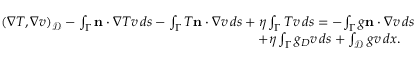<formula> <loc_0><loc_0><loc_500><loc_500>\begin{array} { r } { ( \nabla T , \nabla v ) _ { \mathcal { D } } - \int _ { \Gamma } { n } \cdot { \nabla } T v \, d s - { \int _ { \Gamma } T { n } \cdot { \nabla } v \, d s } + { \eta \int _ { \Gamma } T v \, d s } = - { \int _ { \Gamma } g { n } \cdot { \nabla } v \, d s } } \\ { + { \eta \int _ { \Gamma } g _ { D } v \, d s } + \int _ { \mathcal { D } } g v \, d x . \quad } \end{array}</formula> 